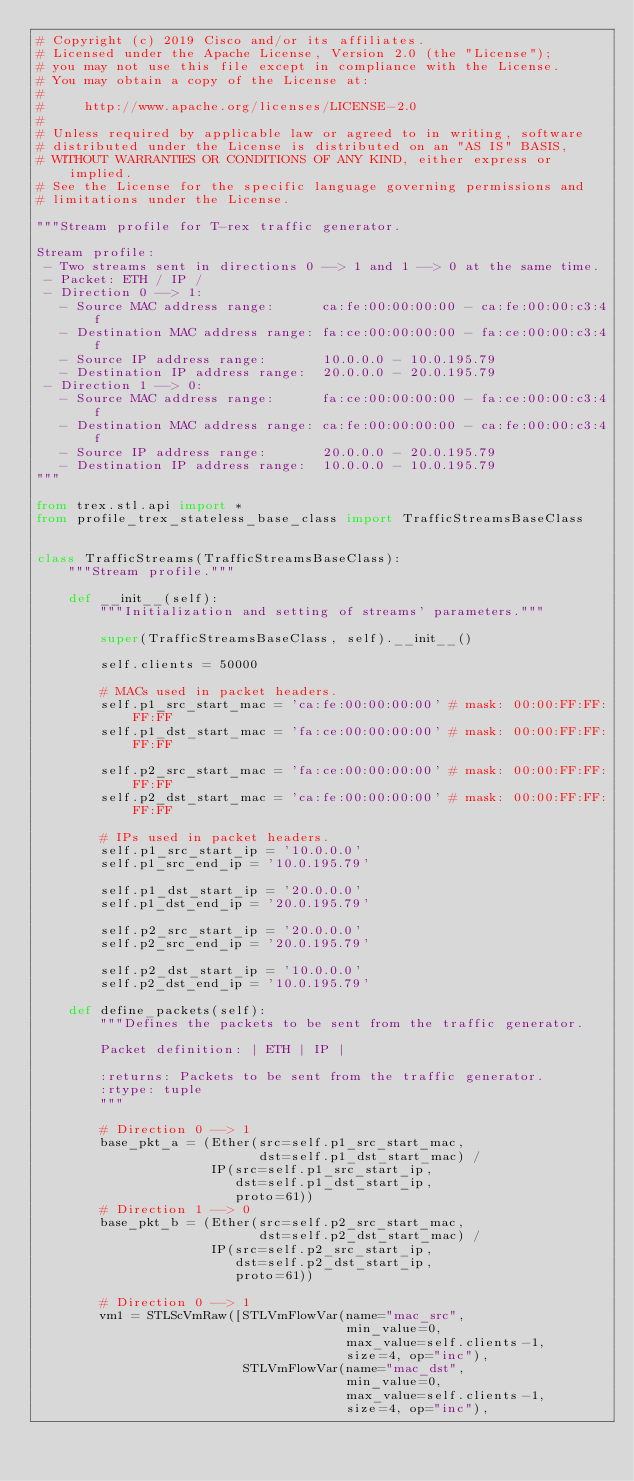<code> <loc_0><loc_0><loc_500><loc_500><_Python_># Copyright (c) 2019 Cisco and/or its affiliates.
# Licensed under the Apache License, Version 2.0 (the "License");
# you may not use this file except in compliance with the License.
# You may obtain a copy of the License at:
#
#     http://www.apache.org/licenses/LICENSE-2.0
#
# Unless required by applicable law or agreed to in writing, software
# distributed under the License is distributed on an "AS IS" BASIS,
# WITHOUT WARRANTIES OR CONDITIONS OF ANY KIND, either express or implied.
# See the License for the specific language governing permissions and
# limitations under the License.

"""Stream profile for T-rex traffic generator.

Stream profile:
 - Two streams sent in directions 0 --> 1 and 1 --> 0 at the same time.
 - Packet: ETH / IP /
 - Direction 0 --> 1:
   - Source MAC address range:      ca:fe:00:00:00:00 - ca:fe:00:00:c3:4f
   - Destination MAC address range: fa:ce:00:00:00:00 - fa:ce:00:00:c3:4f
   - Source IP address range:       10.0.0.0 - 10.0.195.79
   - Destination IP address range:  20.0.0.0 - 20.0.195.79
 - Direction 1 --> 0:
   - Source MAC address range:      fa:ce:00:00:00:00 - fa:ce:00:00:c3:4f
   - Destination MAC address range: ca:fe:00:00:00:00 - ca:fe:00:00:c3:4f
   - Source IP address range:       20.0.0.0 - 20.0.195.79
   - Destination IP address range:  10.0.0.0 - 10.0.195.79
"""

from trex.stl.api import *
from profile_trex_stateless_base_class import TrafficStreamsBaseClass


class TrafficStreams(TrafficStreamsBaseClass):
    """Stream profile."""

    def __init__(self):
        """Initialization and setting of streams' parameters."""

        super(TrafficStreamsBaseClass, self).__init__()

        self.clients = 50000

        # MACs used in packet headers.
        self.p1_src_start_mac = 'ca:fe:00:00:00:00' # mask: 00:00:FF:FF:FF:FF
        self.p1_dst_start_mac = 'fa:ce:00:00:00:00' # mask: 00:00:FF:FF:FF:FF

        self.p2_src_start_mac = 'fa:ce:00:00:00:00' # mask: 00:00:FF:FF:FF:FF
        self.p2_dst_start_mac = 'ca:fe:00:00:00:00' # mask: 00:00:FF:FF:FF:FF

        # IPs used in packet headers.
        self.p1_src_start_ip = '10.0.0.0'
        self.p1_src_end_ip = '10.0.195.79'

        self.p1_dst_start_ip = '20.0.0.0'
        self.p1_dst_end_ip = '20.0.195.79'

        self.p2_src_start_ip = '20.0.0.0'
        self.p2_src_end_ip = '20.0.195.79'

        self.p2_dst_start_ip = '10.0.0.0'
        self.p2_dst_end_ip = '10.0.195.79'

    def define_packets(self):
        """Defines the packets to be sent from the traffic generator.

        Packet definition: | ETH | IP |

        :returns: Packets to be sent from the traffic generator.
        :rtype: tuple
        """

        # Direction 0 --> 1
        base_pkt_a = (Ether(src=self.p1_src_start_mac,
                            dst=self.p1_dst_start_mac) /
                      IP(src=self.p1_src_start_ip,
                         dst=self.p1_dst_start_ip,
                         proto=61))
        # Direction 1 --> 0
        base_pkt_b = (Ether(src=self.p2_src_start_mac,
                            dst=self.p2_dst_start_mac) /
                      IP(src=self.p2_src_start_ip,
                         dst=self.p2_dst_start_ip,
                         proto=61))

        # Direction 0 --> 1
        vm1 = STLScVmRaw([STLVmFlowVar(name="mac_src",
                                       min_value=0,
                                       max_value=self.clients-1,
                                       size=4, op="inc"),
                          STLVmFlowVar(name="mac_dst",
                                       min_value=0,
                                       max_value=self.clients-1,
                                       size=4, op="inc"),</code> 